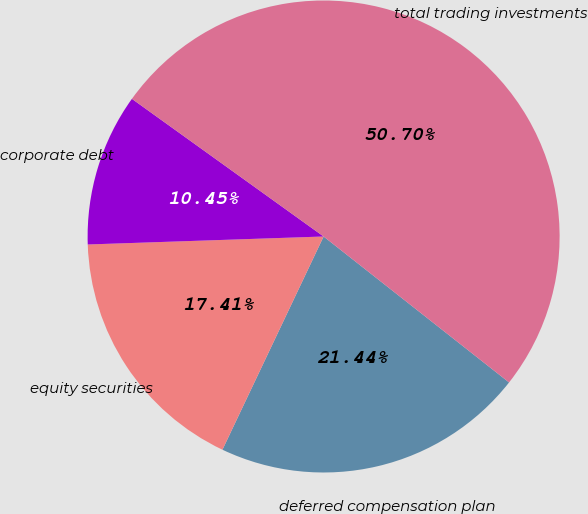<chart> <loc_0><loc_0><loc_500><loc_500><pie_chart><fcel>deferred compensation plan<fcel>equity securities<fcel>corporate debt<fcel>total trading investments<nl><fcel>21.44%<fcel>17.41%<fcel>10.45%<fcel>50.7%<nl></chart> 